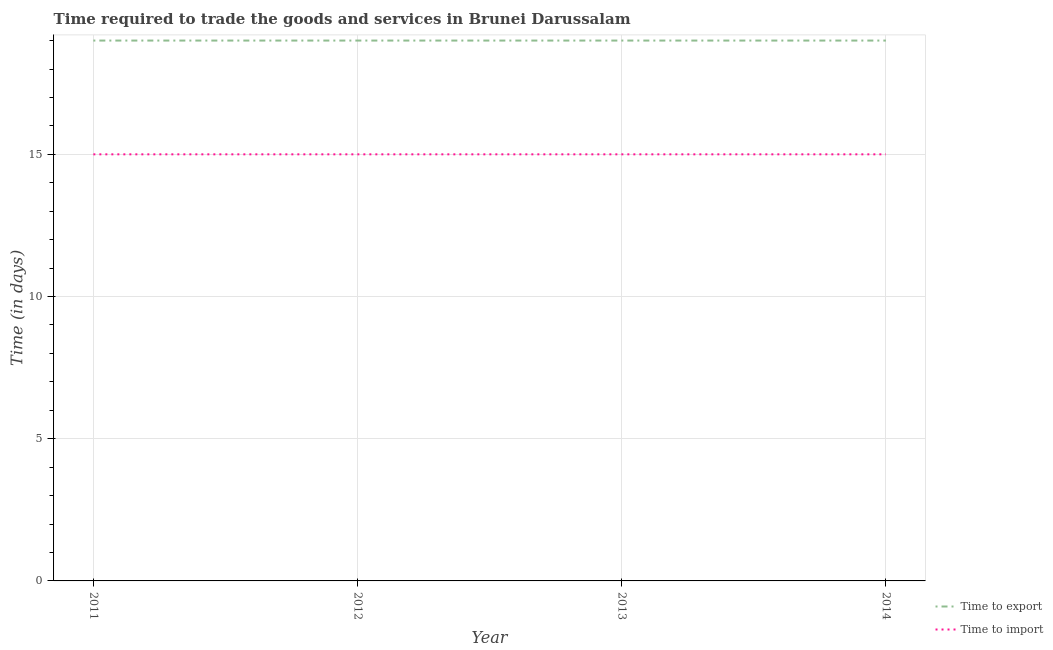How many different coloured lines are there?
Your answer should be very brief. 2. What is the time to export in 2013?
Your answer should be very brief. 19. Across all years, what is the maximum time to import?
Offer a very short reply. 15. Across all years, what is the minimum time to export?
Give a very brief answer. 19. In which year was the time to export maximum?
Your answer should be very brief. 2011. In which year was the time to import minimum?
Provide a short and direct response. 2011. What is the total time to export in the graph?
Give a very brief answer. 76. What is the difference between the time to export in 2011 and that in 2014?
Your response must be concise. 0. What is the difference between the time to import in 2014 and the time to export in 2011?
Provide a succinct answer. -4. In the year 2011, what is the difference between the time to export and time to import?
Offer a very short reply. 4. In how many years, is the time to export greater than 16 days?
Your response must be concise. 4. What is the ratio of the time to export in 2012 to that in 2013?
Provide a short and direct response. 1. Is the time to export in 2011 less than that in 2013?
Your answer should be very brief. No. What is the difference between the highest and the second highest time to export?
Make the answer very short. 0. Is the sum of the time to import in 2012 and 2013 greater than the maximum time to export across all years?
Your answer should be very brief. Yes. Is the time to export strictly greater than the time to import over the years?
Your response must be concise. Yes. How many lines are there?
Your response must be concise. 2. What is the difference between two consecutive major ticks on the Y-axis?
Provide a short and direct response. 5. Where does the legend appear in the graph?
Your response must be concise. Bottom right. How are the legend labels stacked?
Give a very brief answer. Vertical. What is the title of the graph?
Provide a short and direct response. Time required to trade the goods and services in Brunei Darussalam. Does "Forest land" appear as one of the legend labels in the graph?
Your answer should be very brief. No. What is the label or title of the Y-axis?
Make the answer very short. Time (in days). What is the Time (in days) in Time to export in 2012?
Keep it short and to the point. 19. What is the Time (in days) of Time to import in 2014?
Keep it short and to the point. 15. What is the total Time (in days) of Time to export in the graph?
Make the answer very short. 76. What is the difference between the Time (in days) in Time to import in 2011 and that in 2012?
Give a very brief answer. 0. What is the difference between the Time (in days) in Time to export in 2011 and that in 2013?
Offer a very short reply. 0. What is the difference between the Time (in days) of Time to export in 2011 and that in 2014?
Offer a terse response. 0. What is the difference between the Time (in days) of Time to export in 2012 and that in 2013?
Provide a short and direct response. 0. What is the difference between the Time (in days) of Time to import in 2012 and that in 2013?
Ensure brevity in your answer.  0. What is the difference between the Time (in days) of Time to export in 2012 and that in 2014?
Make the answer very short. 0. What is the difference between the Time (in days) of Time to export in 2013 and that in 2014?
Keep it short and to the point. 0. What is the difference between the Time (in days) of Time to import in 2013 and that in 2014?
Provide a succinct answer. 0. What is the difference between the Time (in days) of Time to export in 2011 and the Time (in days) of Time to import in 2012?
Offer a very short reply. 4. What is the difference between the Time (in days) of Time to export in 2011 and the Time (in days) of Time to import in 2014?
Give a very brief answer. 4. What is the difference between the Time (in days) in Time to export in 2012 and the Time (in days) in Time to import in 2014?
Offer a terse response. 4. What is the difference between the Time (in days) in Time to export in 2013 and the Time (in days) in Time to import in 2014?
Offer a terse response. 4. What is the average Time (in days) in Time to export per year?
Provide a short and direct response. 19. In the year 2011, what is the difference between the Time (in days) of Time to export and Time (in days) of Time to import?
Ensure brevity in your answer.  4. In the year 2012, what is the difference between the Time (in days) of Time to export and Time (in days) of Time to import?
Give a very brief answer. 4. In the year 2014, what is the difference between the Time (in days) in Time to export and Time (in days) in Time to import?
Your response must be concise. 4. What is the ratio of the Time (in days) of Time to import in 2011 to that in 2012?
Your answer should be very brief. 1. What is the ratio of the Time (in days) of Time to export in 2011 to that in 2013?
Offer a terse response. 1. What is the ratio of the Time (in days) of Time to import in 2011 to that in 2014?
Give a very brief answer. 1. What is the ratio of the Time (in days) in Time to export in 2013 to that in 2014?
Offer a terse response. 1. What is the ratio of the Time (in days) in Time to import in 2013 to that in 2014?
Your response must be concise. 1. What is the difference between the highest and the second highest Time (in days) in Time to import?
Provide a succinct answer. 0. 